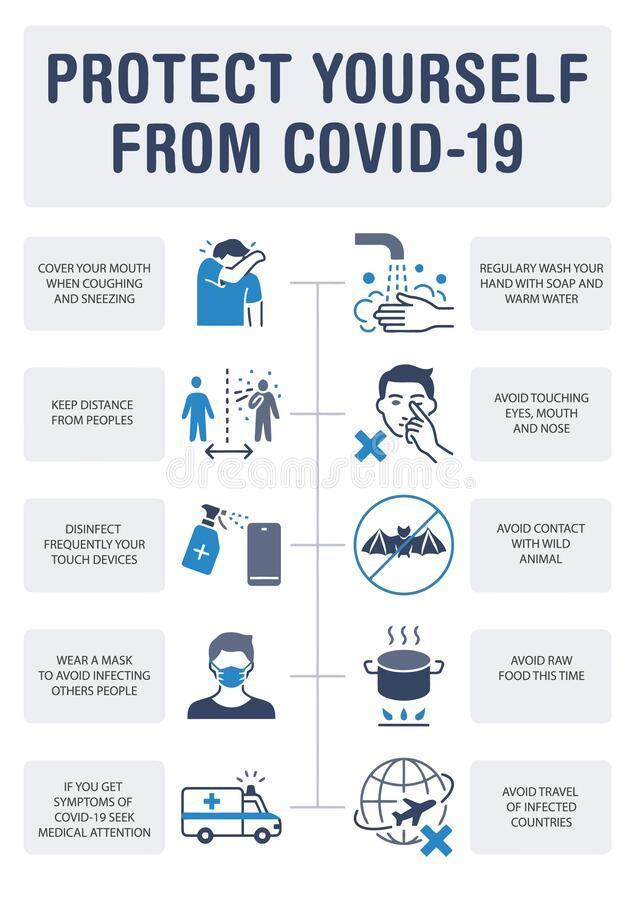How many people are with a mask in this infographic?
Answer the question with a short phrase. 1 How many animals are in this infographic? 1 